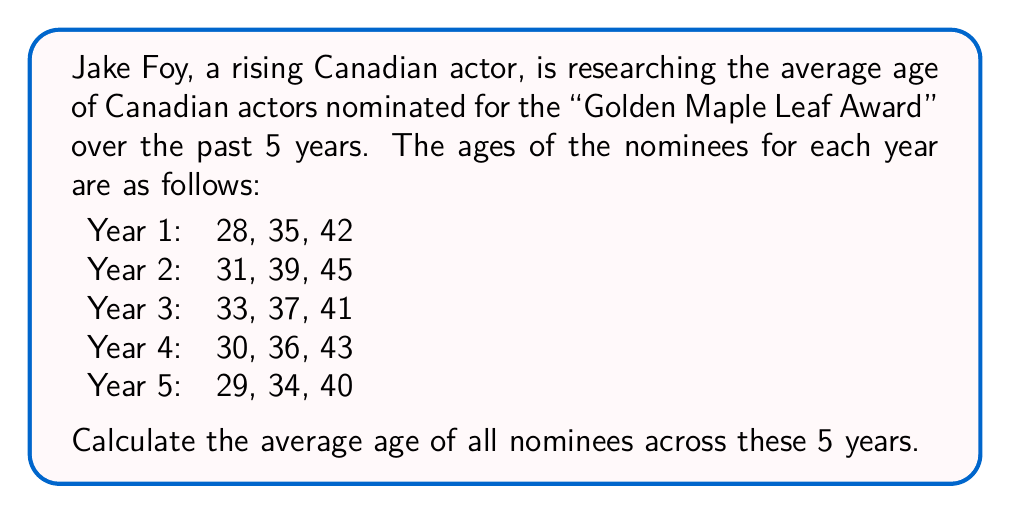Solve this math problem. Let's approach this step-by-step:

1) First, we need to find the sum of all ages:

   Year 1: 28 + 35 + 42 = 105
   Year 2: 31 + 39 + 45 = 115
   Year 3: 33 + 37 + 41 = 111
   Year 4: 30 + 36 + 43 = 109
   Year 5: 29 + 34 + 40 = 103

2) Now, let's add up these sums:

   $$ 105 + 115 + 111 + 109 + 103 = 543 $$

3) To find the total number of nominees, we multiply the number of years by the number of nominees per year:

   $$ 5 \text{ years} \times 3 \text{ nominees} = 15 \text{ total nominees} $$

4) The average age is calculated by dividing the sum of all ages by the total number of nominees:

   $$ \text{Average Age} = \frac{\text{Sum of all ages}}{\text{Total number of nominees}} = \frac{543}{15} = 36.2 $$

Therefore, the average age of Canadian actors nominated for the "Golden Maple Leaf Award" over these 5 years is 36.2 years.
Answer: 36.2 years 